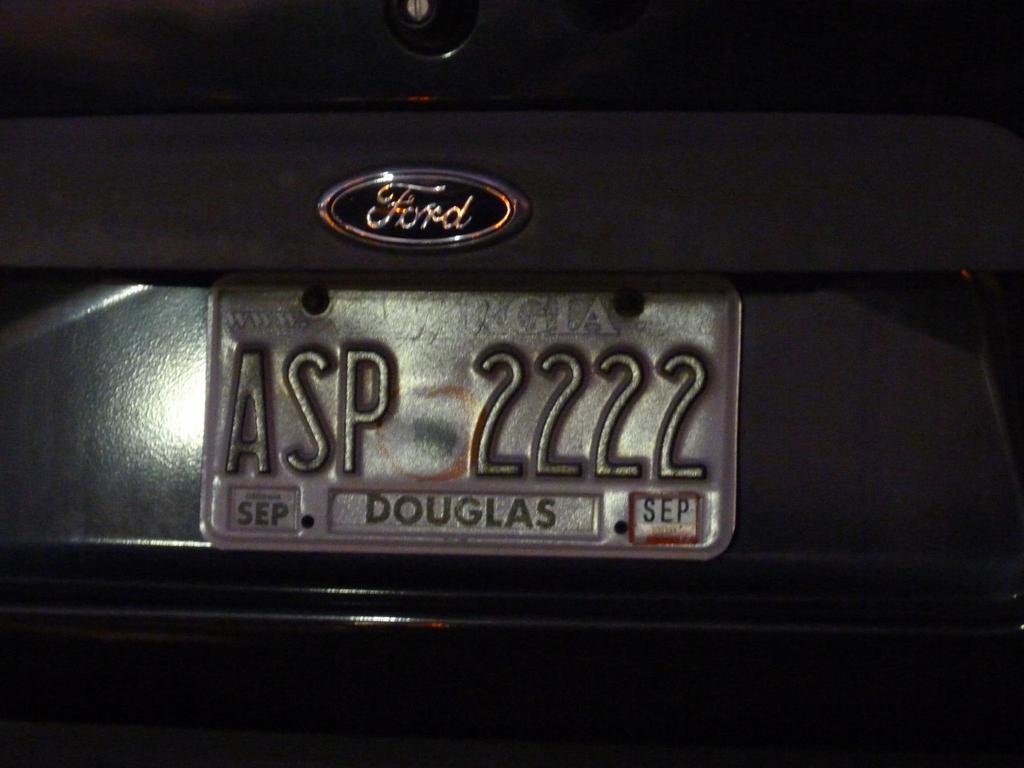How would you summarize this image in a sentence or two? In this image we can see the number plate of a vehicle. 